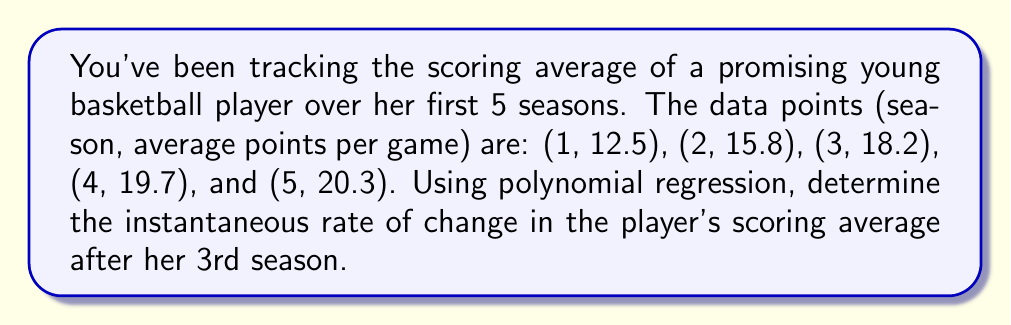Can you answer this question? 1) First, we need to fit a polynomial to the given data points. Let's use a quadratic polynomial of the form $y = ax^2 + bx + c$, where $y$ is the scoring average and $x$ is the season number.

2) We can use a computer algebra system or statistical software to perform the quadratic regression. The resulting polynomial is:

   $y = -0.7x^2 + 5.9x + 7.5$

3) To find the instantaneous rate of change after the 3rd season, we need to find the derivative of this function and evaluate it at $x = 3$.

4) The derivative of $y = -0.7x^2 + 5.9x + 7.5$ is:

   $\frac{dy}{dx} = -1.4x + 5.9$

5) Evaluating this at $x = 3$:

   $\frac{dy}{dx}|_{x=3} = -1.4(3) + 5.9 = -4.2 + 5.9 = 1.7$

6) Therefore, the instantaneous rate of change in the player's scoring average after her 3rd season is 1.7 points per season.
Answer: 1.7 points per season 